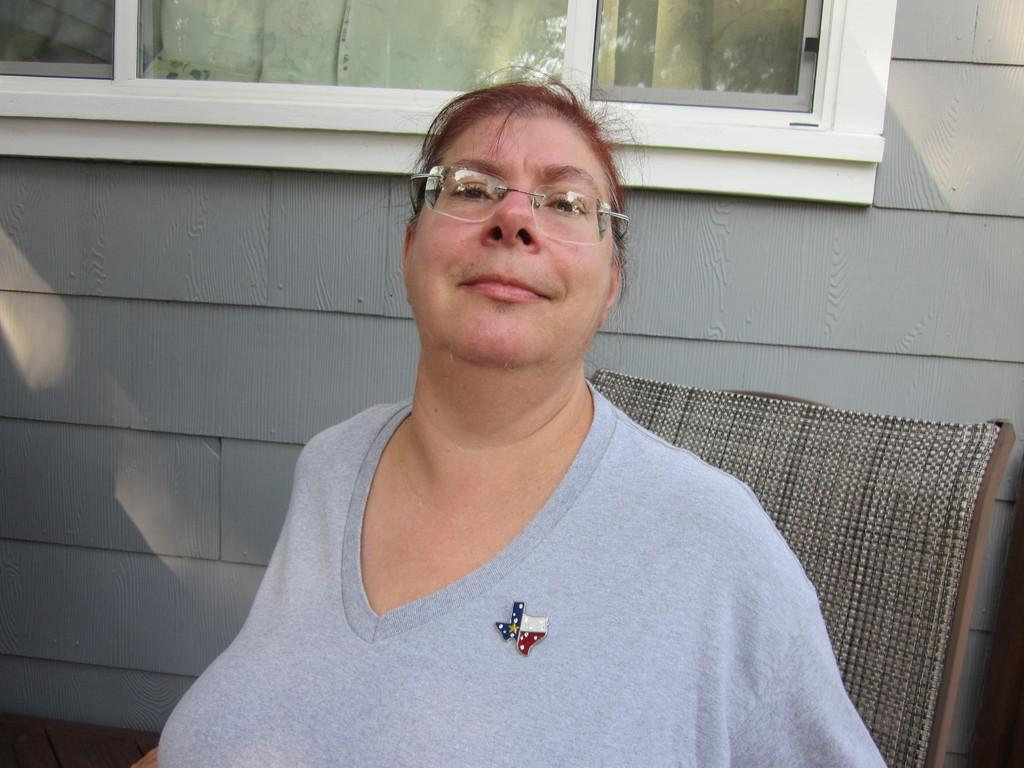Who is present in the image? There is a woman in the image. What is the woman doing in the image? The woman is sitting on a chair and smiling. What can be seen in the background of the image? There is a wall and a window in the background of the image. What is the woman's tendency to amuse herself with her mouth in the image? There is no information about the woman's tendency to amuse herself with her mouth in the image. 